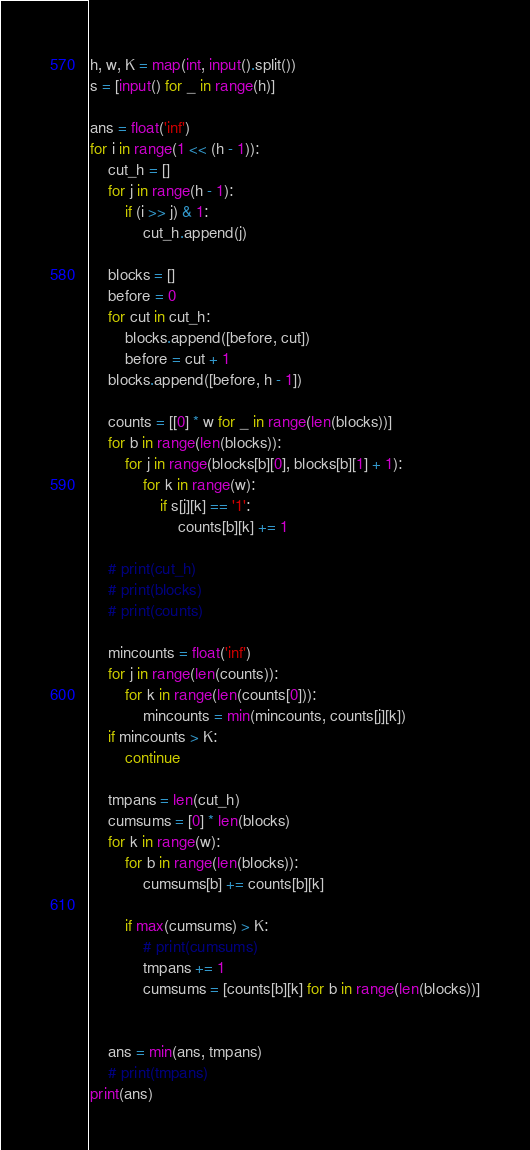<code> <loc_0><loc_0><loc_500><loc_500><_Python_>h, w, K = map(int, input().split())
s = [input() for _ in range(h)]

ans = float('inf')
for i in range(1 << (h - 1)):
    cut_h = []
    for j in range(h - 1):
        if (i >> j) & 1:
            cut_h.append(j)

    blocks = []
    before = 0
    for cut in cut_h:
        blocks.append([before, cut])
        before = cut + 1
    blocks.append([before, h - 1])

    counts = [[0] * w for _ in range(len(blocks))]
    for b in range(len(blocks)):
        for j in range(blocks[b][0], blocks[b][1] + 1):
            for k in range(w):
                if s[j][k] == '1':
                    counts[b][k] += 1

    # print(cut_h)
    # print(blocks)
    # print(counts)

    mincounts = float('inf')
    for j in range(len(counts)):
        for k in range(len(counts[0])):
            mincounts = min(mincounts, counts[j][k])
    if mincounts > K:
        continue

    tmpans = len(cut_h)
    cumsums = [0] * len(blocks)
    for k in range(w):
        for b in range(len(blocks)):
            cumsums[b] += counts[b][k]

        if max(cumsums) > K:
            # print(cumsums)
            tmpans += 1
            cumsums = [counts[b][k] for b in range(len(blocks))]


    ans = min(ans, tmpans)
    # print(tmpans)
print(ans)
</code> 